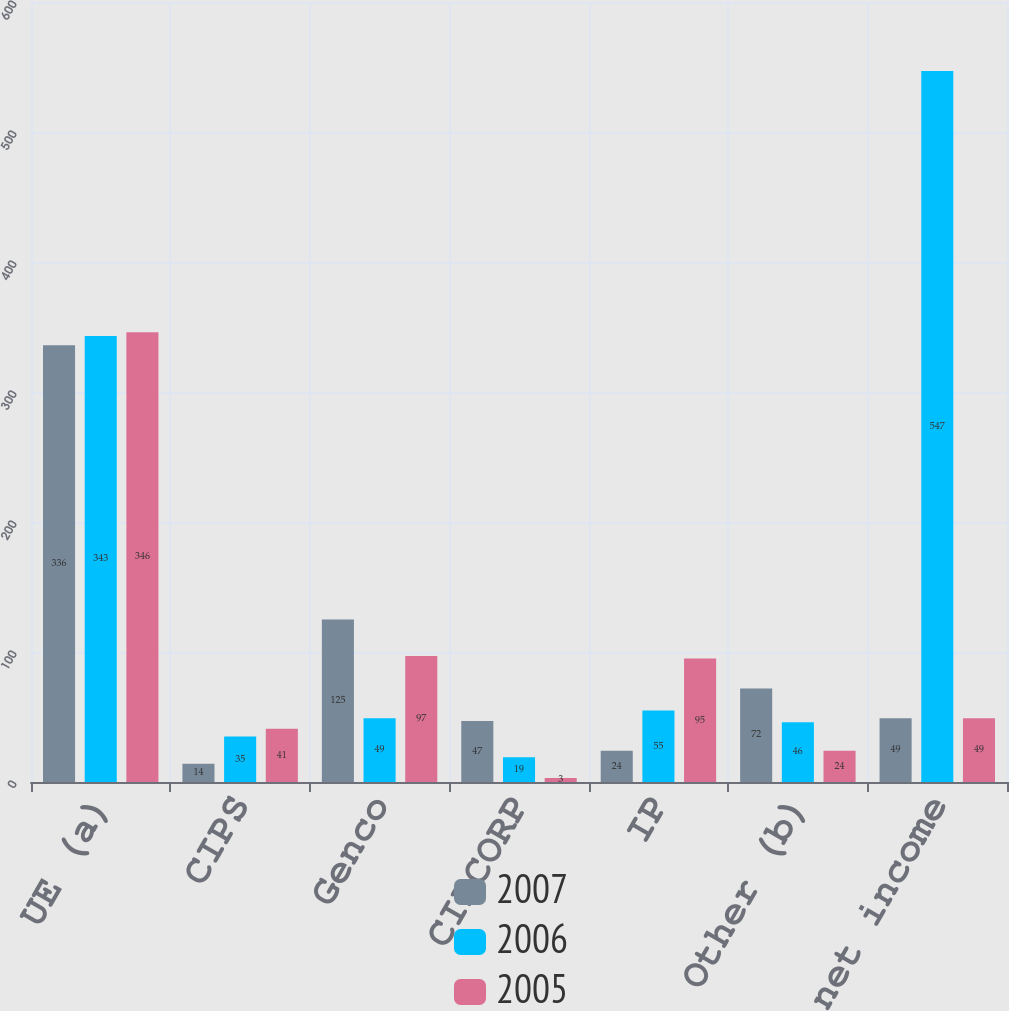Convert chart to OTSL. <chart><loc_0><loc_0><loc_500><loc_500><stacked_bar_chart><ecel><fcel>UE (a)<fcel>CIPS<fcel>Genco<fcel>CILCORP<fcel>IP<fcel>Other (b)<fcel>Ameren net income<nl><fcel>2007<fcel>336<fcel>14<fcel>125<fcel>47<fcel>24<fcel>72<fcel>49<nl><fcel>2006<fcel>343<fcel>35<fcel>49<fcel>19<fcel>55<fcel>46<fcel>547<nl><fcel>2005<fcel>346<fcel>41<fcel>97<fcel>3<fcel>95<fcel>24<fcel>49<nl></chart> 